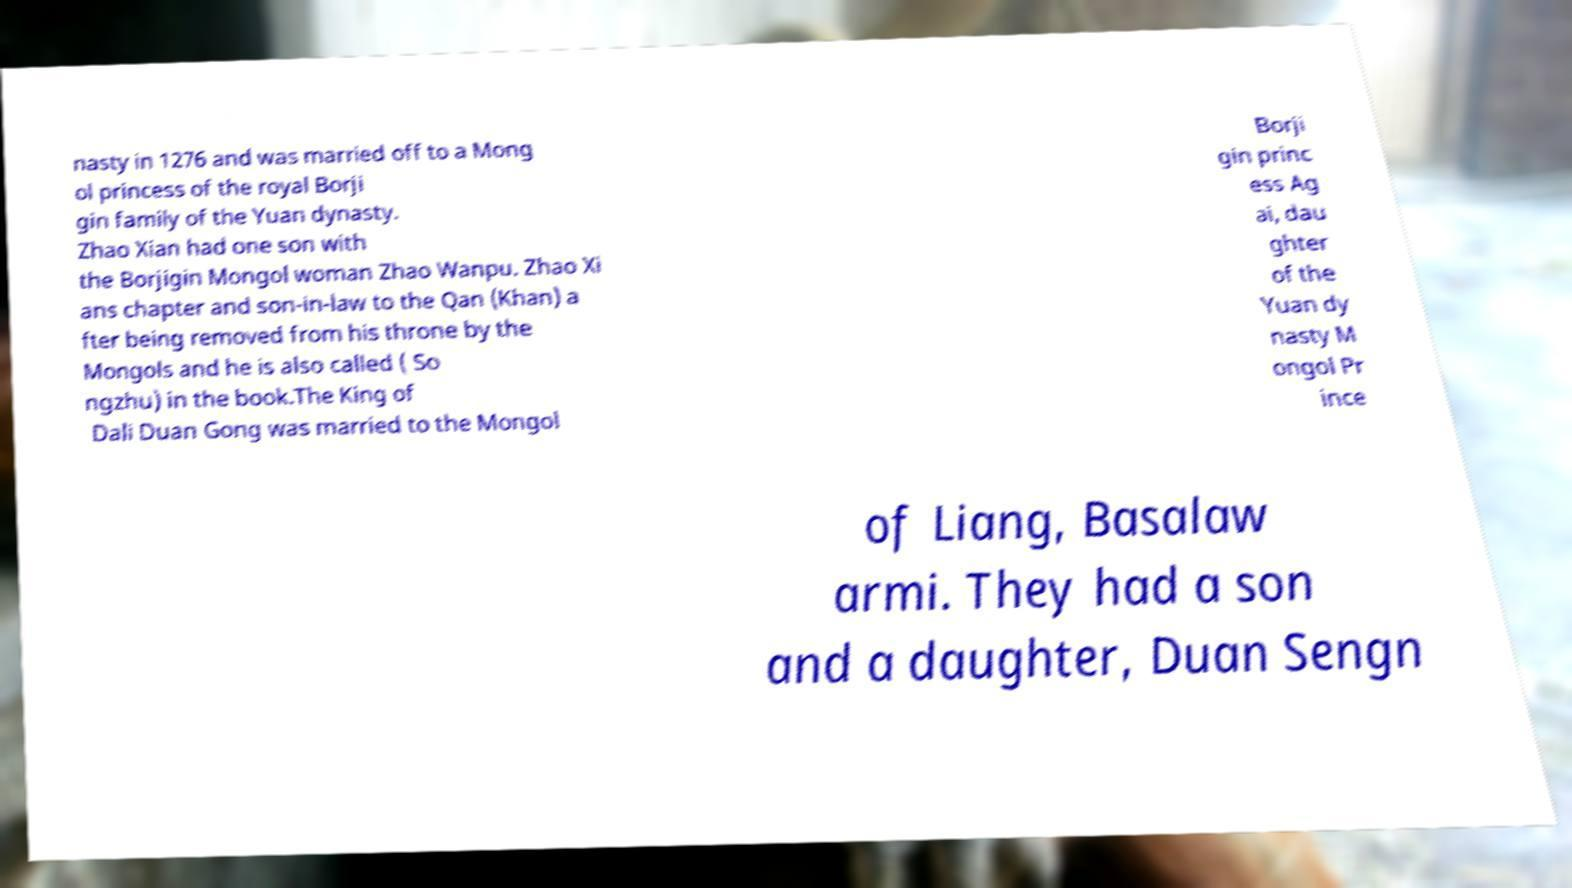There's text embedded in this image that I need extracted. Can you transcribe it verbatim? nasty in 1276 and was married off to a Mong ol princess of the royal Borji gin family of the Yuan dynasty. Zhao Xian had one son with the Borjigin Mongol woman Zhao Wanpu. Zhao Xi ans chapter and son-in-law to the Qan (Khan) a fter being removed from his throne by the Mongols and he is also called ( So ngzhu) in the book.The King of Dali Duan Gong was married to the Mongol Borji gin princ ess Ag ai, dau ghter of the Yuan dy nasty M ongol Pr ince of Liang, Basalaw armi. They had a son and a daughter, Duan Sengn 